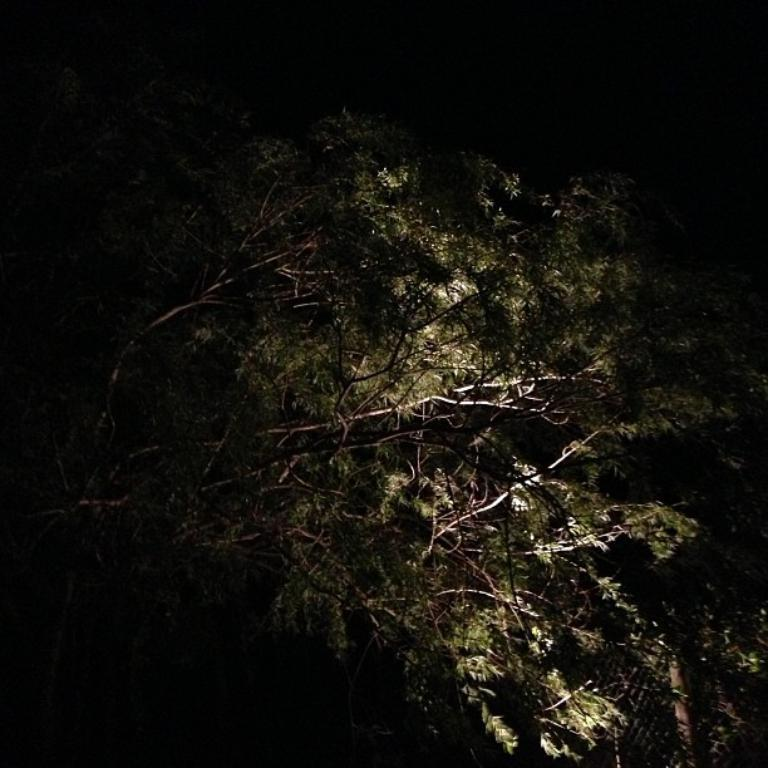What time of day was the image taken? The image was taken at night time. What type of vegetation can be seen in the image? There are trees in the image. How would you describe the overall lighting in the image? The background of the image is dark. What type of lunch is being served in the image? There is no lunch present in the image. Can you see a goat in the image? There is no goat present in the image. 